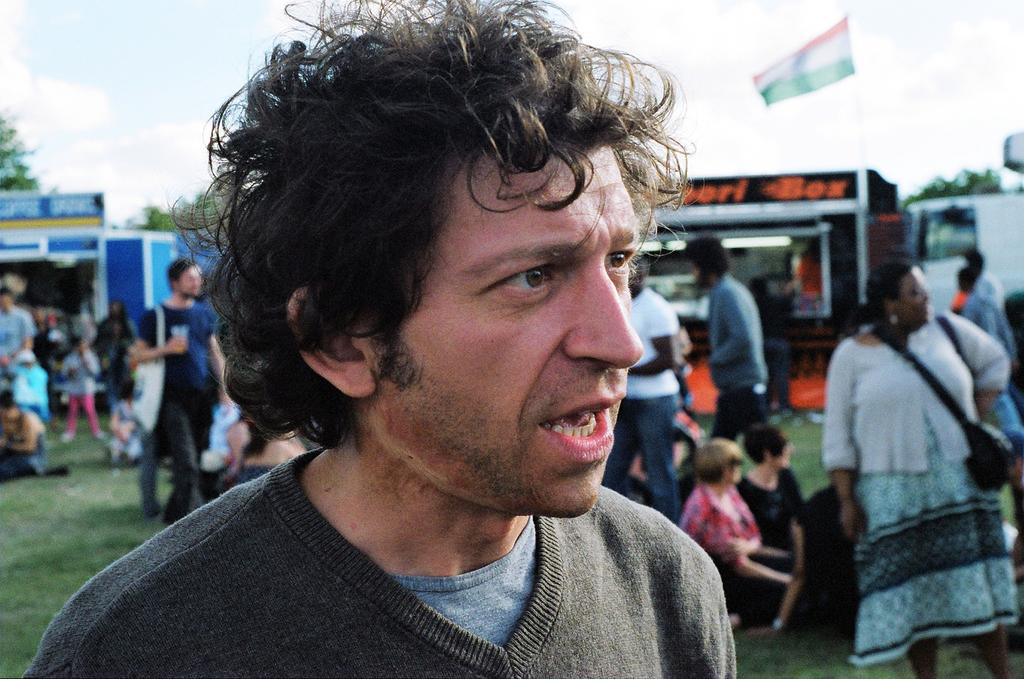How many people are in the image? There are people in the image, but the exact number is not specified. What are some people wearing in the image? Some people are wearing bags in the image. What can be seen in the background of the image? There are sheds and trees in the background of the image. What is the flag's position in the image? The flag is visible in the image. What type of news can be heard coming from the card in the image? There is no card or news present in the image. What is the person holding in the image? The facts do not specify what the person is holding, so we cannot answer this question. 